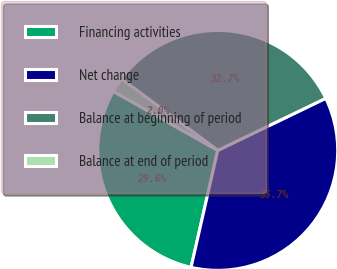Convert chart. <chart><loc_0><loc_0><loc_500><loc_500><pie_chart><fcel>Financing activities<fcel>Net change<fcel>Balance at beginning of period<fcel>Balance at end of period<nl><fcel>29.62%<fcel>35.73%<fcel>32.68%<fcel>1.97%<nl></chart> 